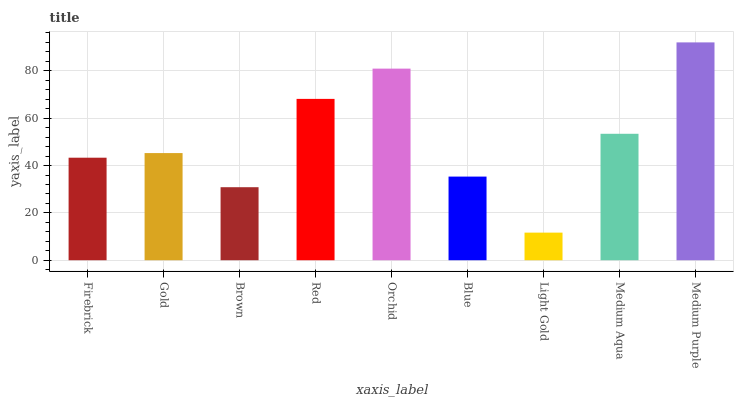Is Light Gold the minimum?
Answer yes or no. Yes. Is Medium Purple the maximum?
Answer yes or no. Yes. Is Gold the minimum?
Answer yes or no. No. Is Gold the maximum?
Answer yes or no. No. Is Gold greater than Firebrick?
Answer yes or no. Yes. Is Firebrick less than Gold?
Answer yes or no. Yes. Is Firebrick greater than Gold?
Answer yes or no. No. Is Gold less than Firebrick?
Answer yes or no. No. Is Gold the high median?
Answer yes or no. Yes. Is Gold the low median?
Answer yes or no. Yes. Is Red the high median?
Answer yes or no. No. Is Medium Aqua the low median?
Answer yes or no. No. 